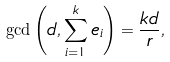Convert formula to latex. <formula><loc_0><loc_0><loc_500><loc_500>\gcd \left ( d , \sum _ { i = 1 } ^ { k } e _ { i } \right ) = \frac { k d } { r } ,</formula> 